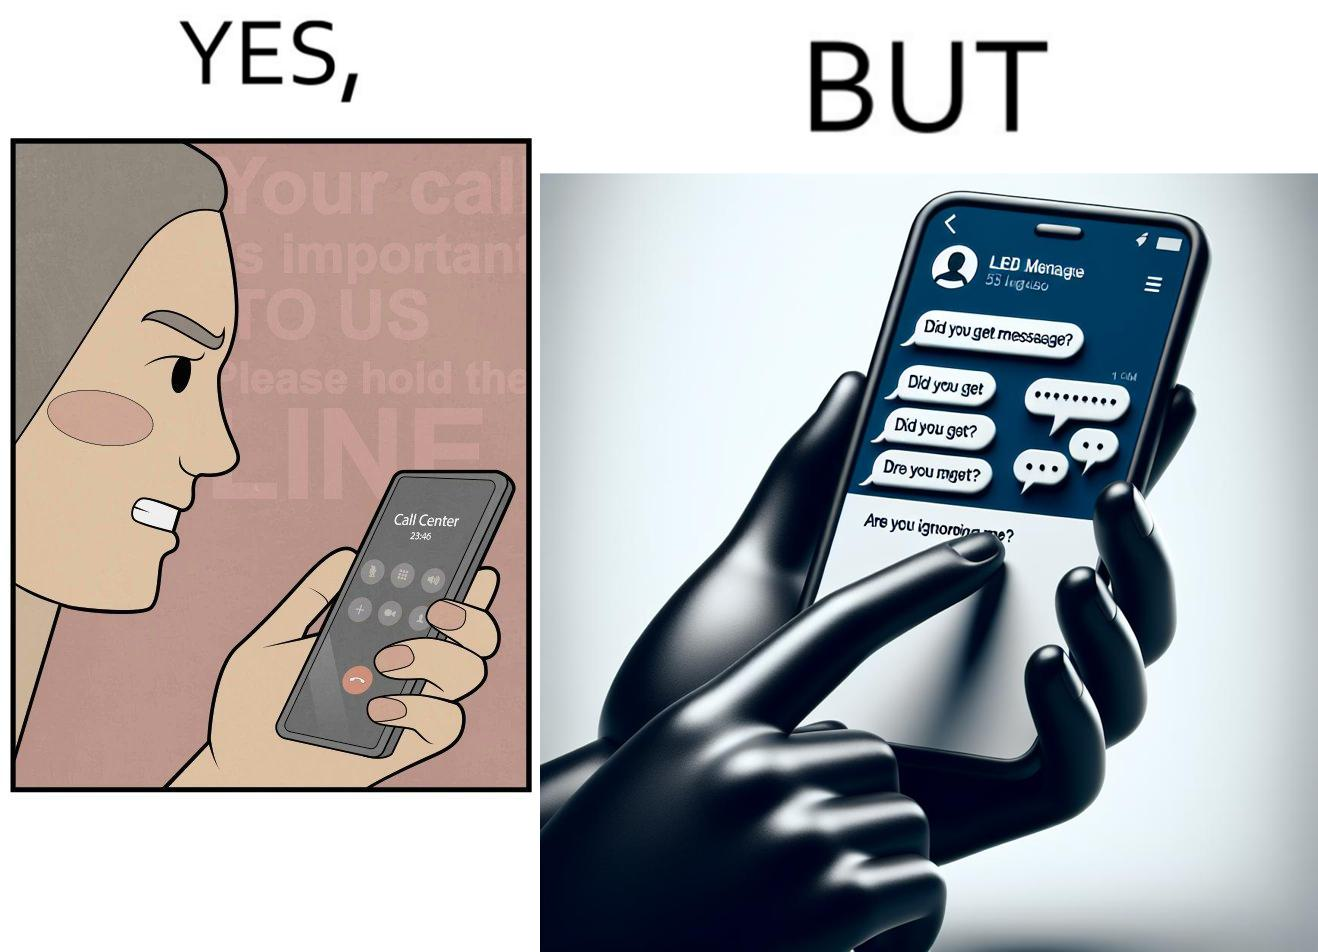What do you see in each half of this image? In the left part of the image: The image shows an annoyed woman talking to the representative in the call center on her mobile phone for over 23 minutes and 45 seconds. In the right part of the image: The image shows the chats of a person on their phone. There are a total of 53 unread chats. In the unanswered chats, the people on the other end are asking if this person got their message or if this person is ignoring them. 